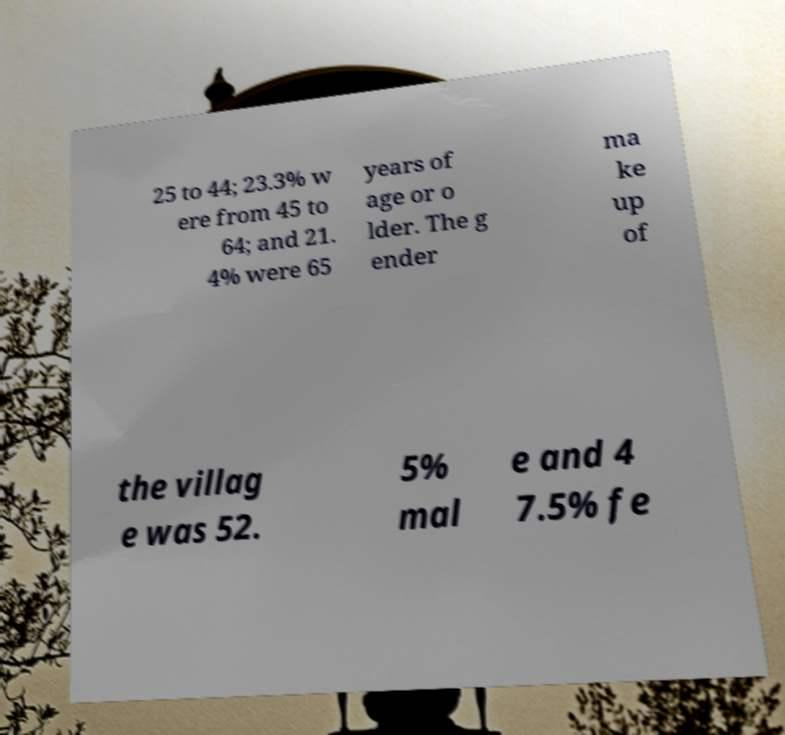Could you extract and type out the text from this image? 25 to 44; 23.3% w ere from 45 to 64; and 21. 4% were 65 years of age or o lder. The g ender ma ke up of the villag e was 52. 5% mal e and 4 7.5% fe 